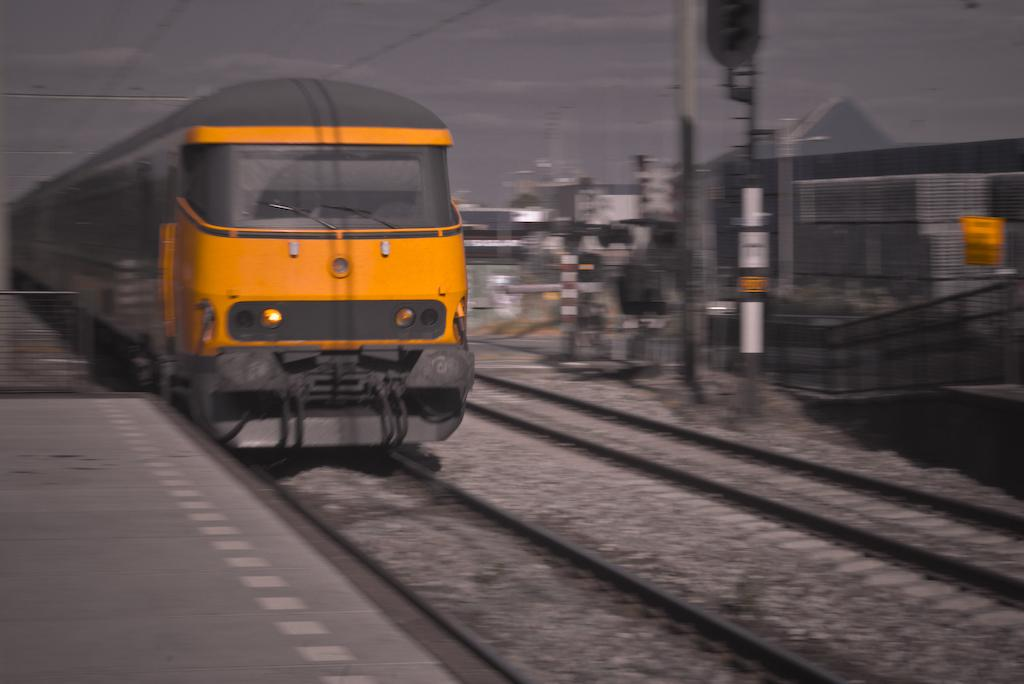What is the main subject of the image? The main subject of the image is a train. What is the train's position in the image? The train is on a track. What can be seen in the background of the image? In the background, there are poles, a fence, and the sky. Are there any additional structures or elements in the image? Yes, there are wires in the image. What type of effect does the chicken have on the train in the image? There is no chicken present in the image, so it cannot have any effect on the train. 